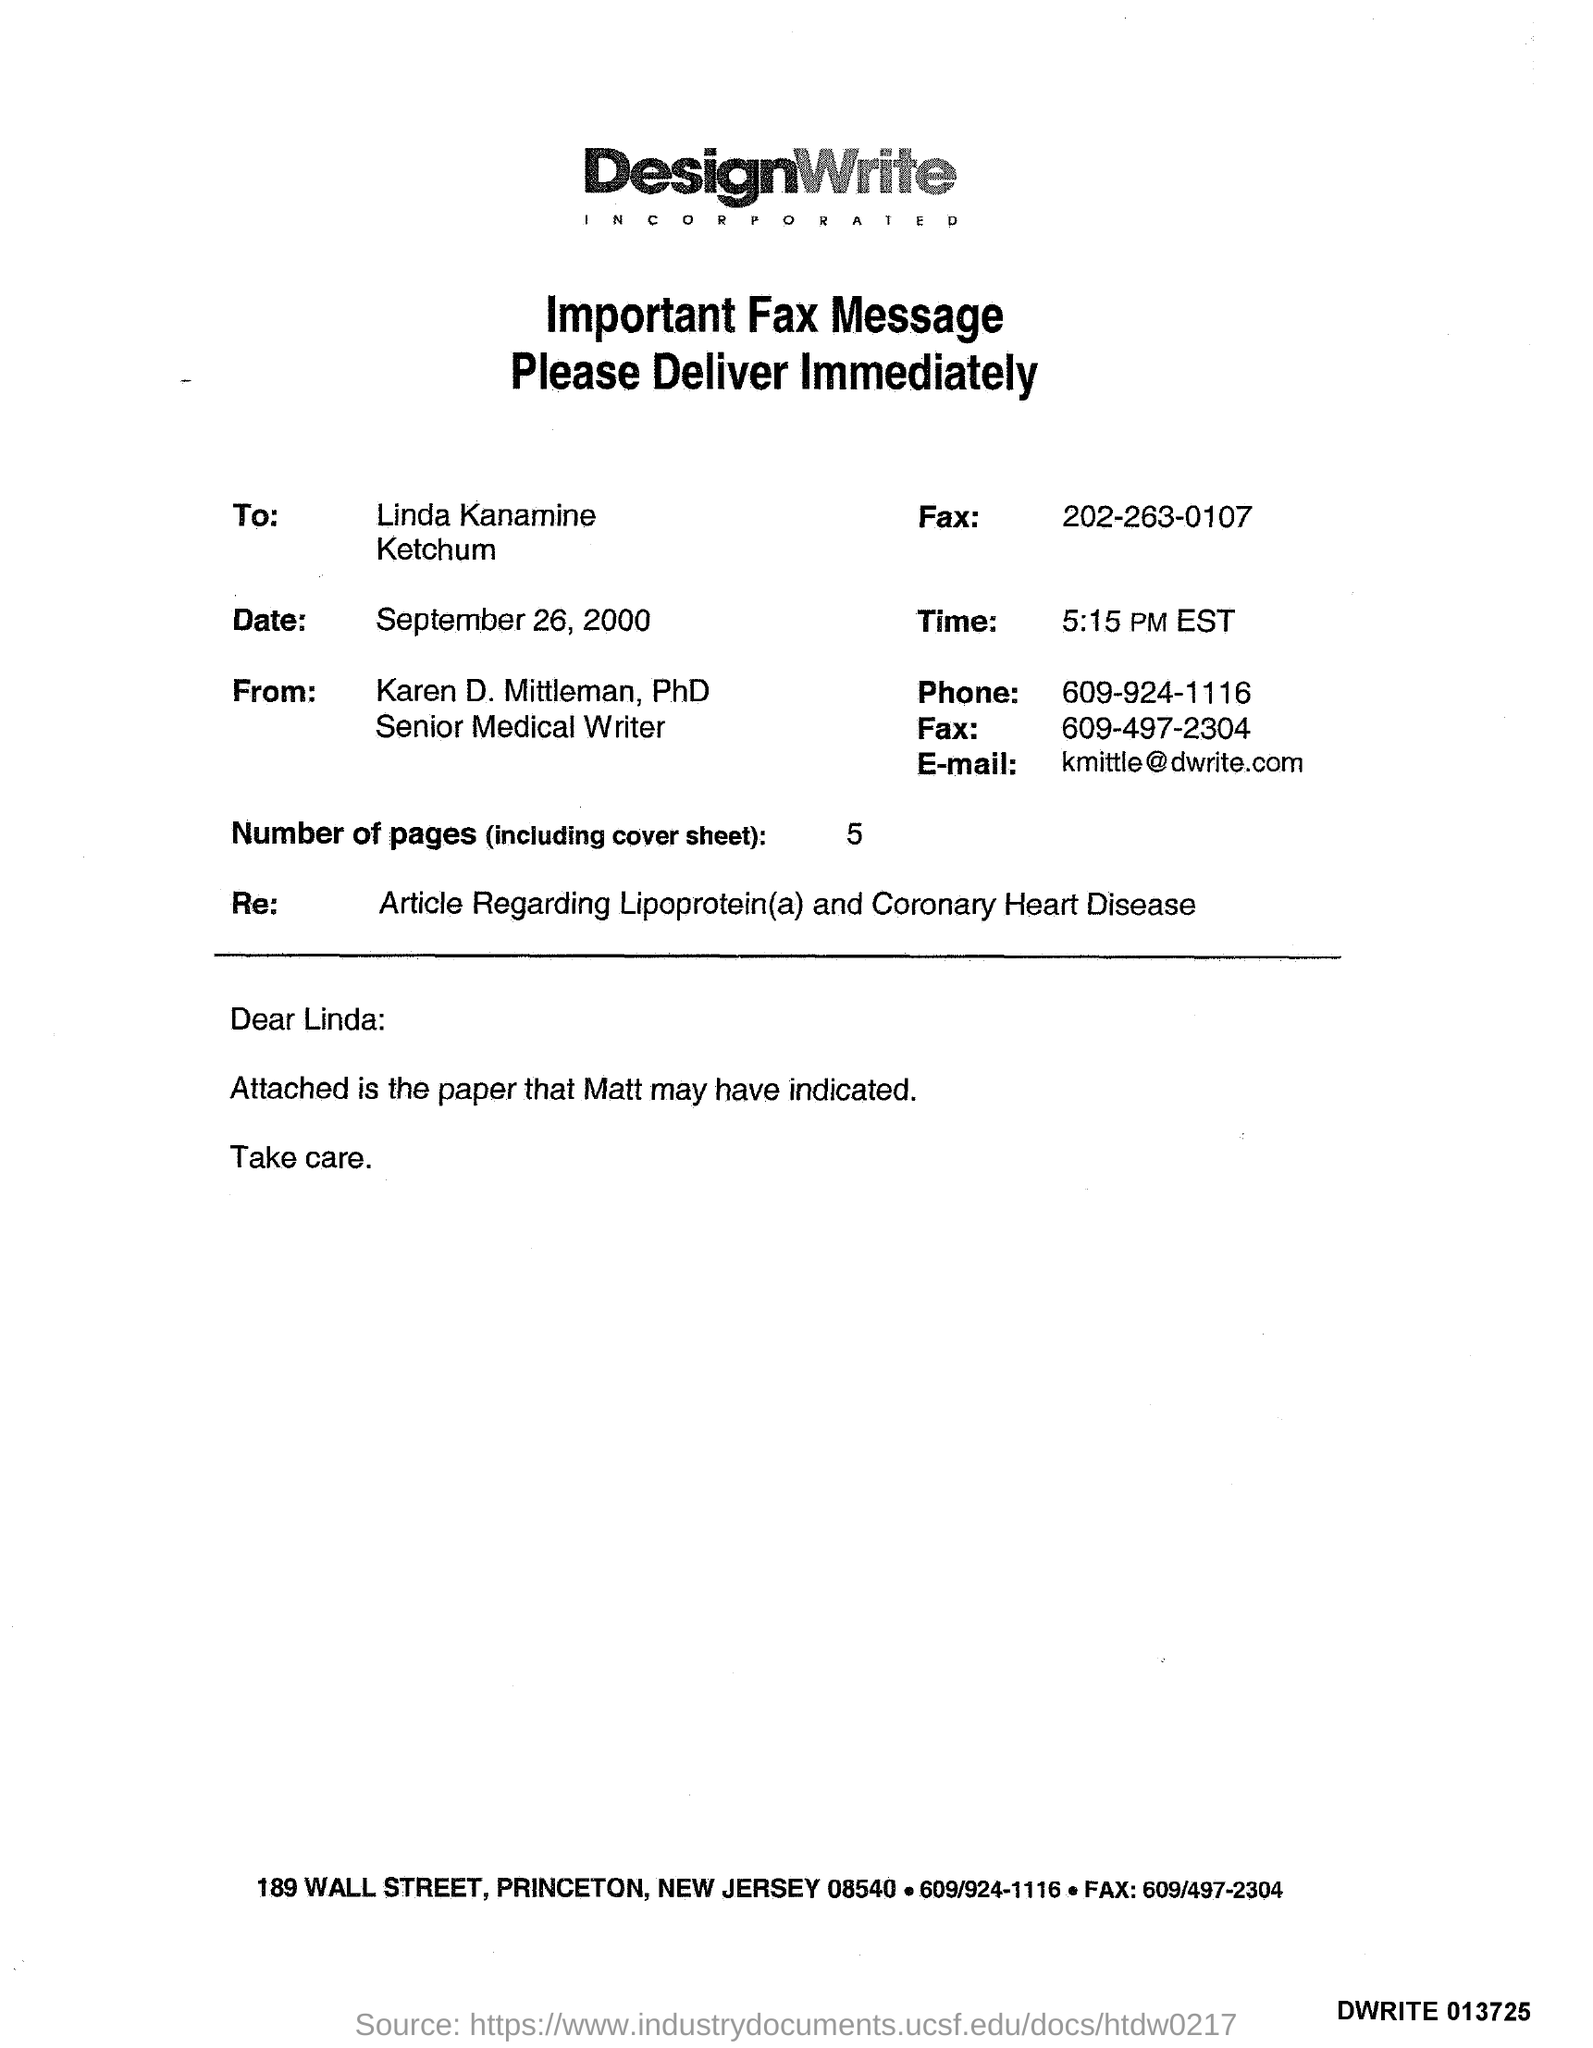Draw attention to some important aspects in this diagram. There are five pages in total. The sender's fax number is 609-497-2304. The sender's phone number is 609-924-1116. Karen Mittleman is the Senior Medical Writer. The receiver fax number is 202-263-0107. 